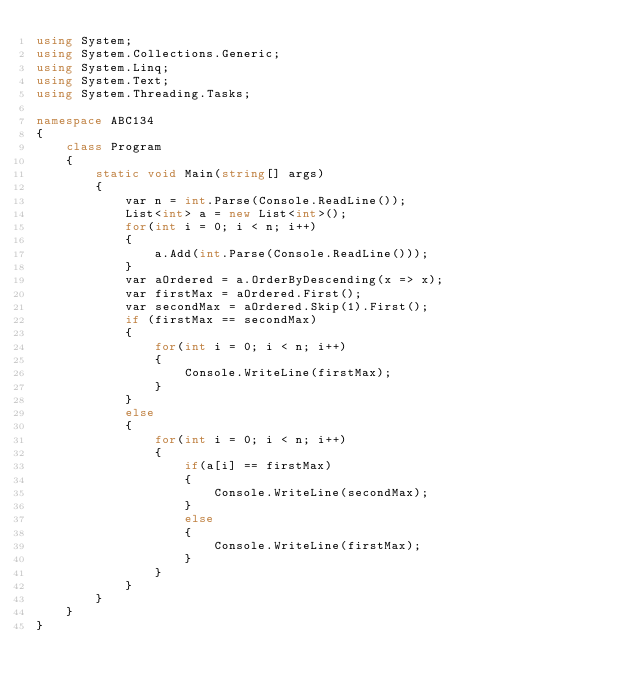<code> <loc_0><loc_0><loc_500><loc_500><_C#_>using System;
using System.Collections.Generic;
using System.Linq;
using System.Text;
using System.Threading.Tasks;

namespace ABC134
{
    class Program
    {
        static void Main(string[] args)
        {
            var n = int.Parse(Console.ReadLine());
            List<int> a = new List<int>();
            for(int i = 0; i < n; i++)
            {
                a.Add(int.Parse(Console.ReadLine()));
            }
            var aOrdered = a.OrderByDescending(x => x);
            var firstMax = aOrdered.First();
            var secondMax = aOrdered.Skip(1).First();
            if (firstMax == secondMax)
            {
                for(int i = 0; i < n; i++)
                {
                    Console.WriteLine(firstMax);
                }
            }
            else
            {
                for(int i = 0; i < n; i++)
                {
                    if(a[i] == firstMax)
                    {
                        Console.WriteLine(secondMax);
                    }
                    else
                    {
                        Console.WriteLine(firstMax);
                    }
                }
            }
        }
    }
}
</code> 